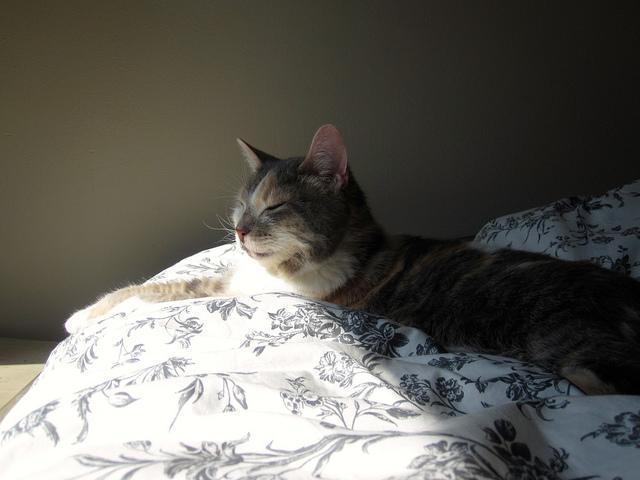How many cats are in the picture?
Give a very brief answer. 1. How many people in this picture are wearing blue hats?
Give a very brief answer. 0. 